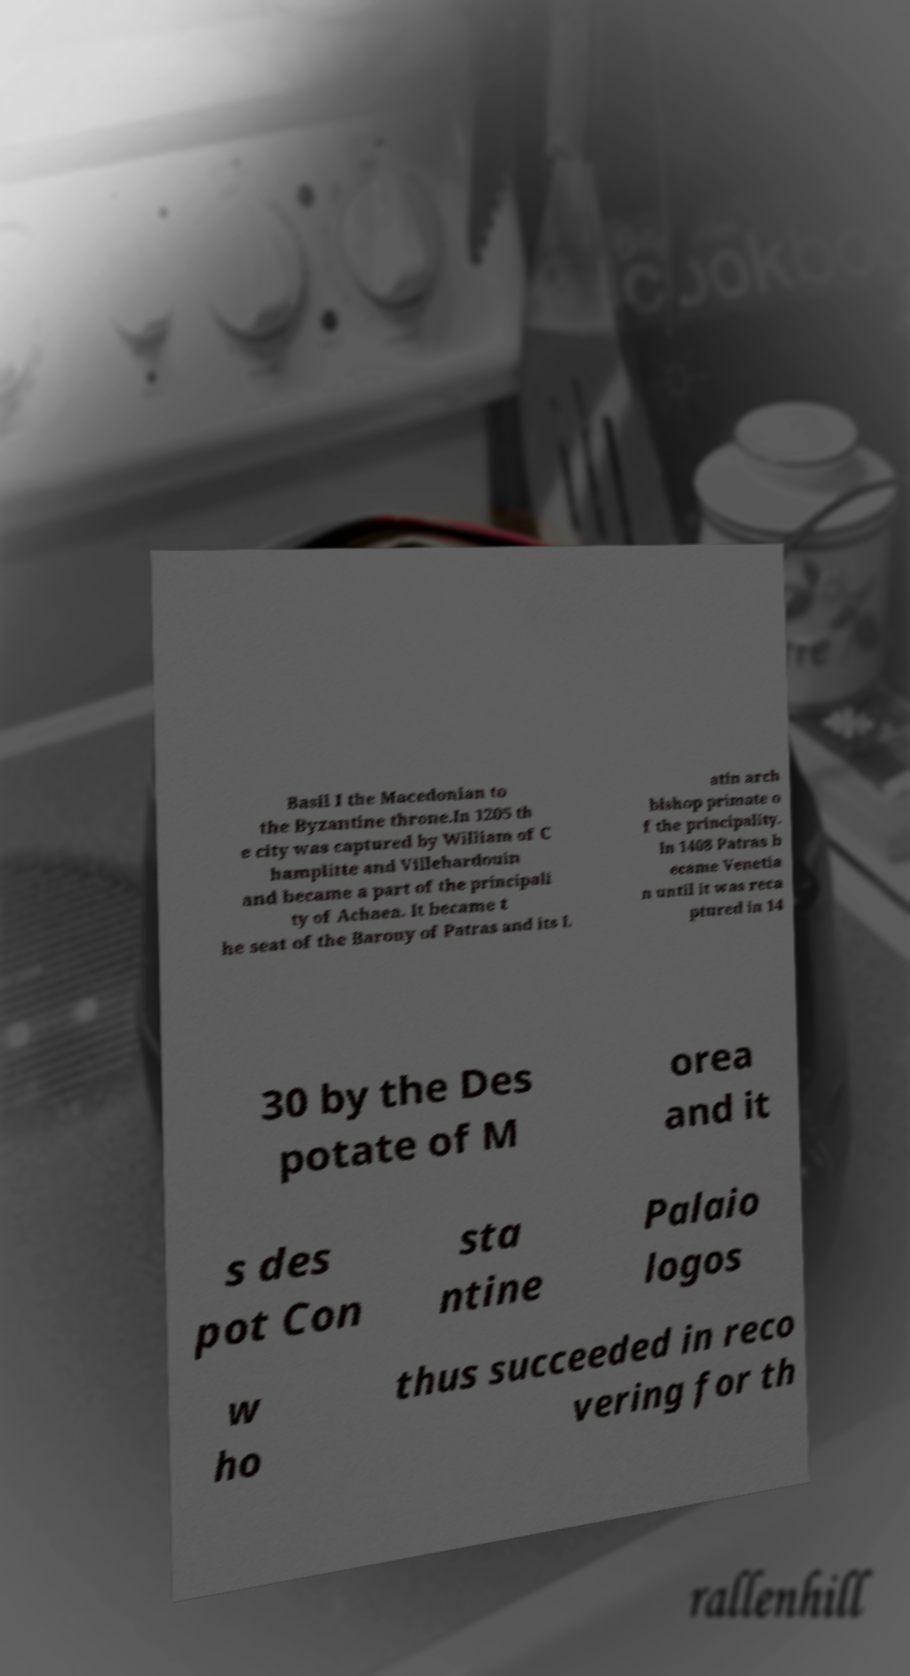Can you accurately transcribe the text from the provided image for me? Basil I the Macedonian to the Byzantine throne.In 1205 th e city was captured by William of C hamplitte and Villehardouin and became a part of the principali ty of Achaea. It became t he seat of the Barony of Patras and its L atin arch bishop primate o f the principality. In 1408 Patras b ecame Venetia n until it was reca ptured in 14 30 by the Des potate of M orea and it s des pot Con sta ntine Palaio logos w ho thus succeeded in reco vering for th 